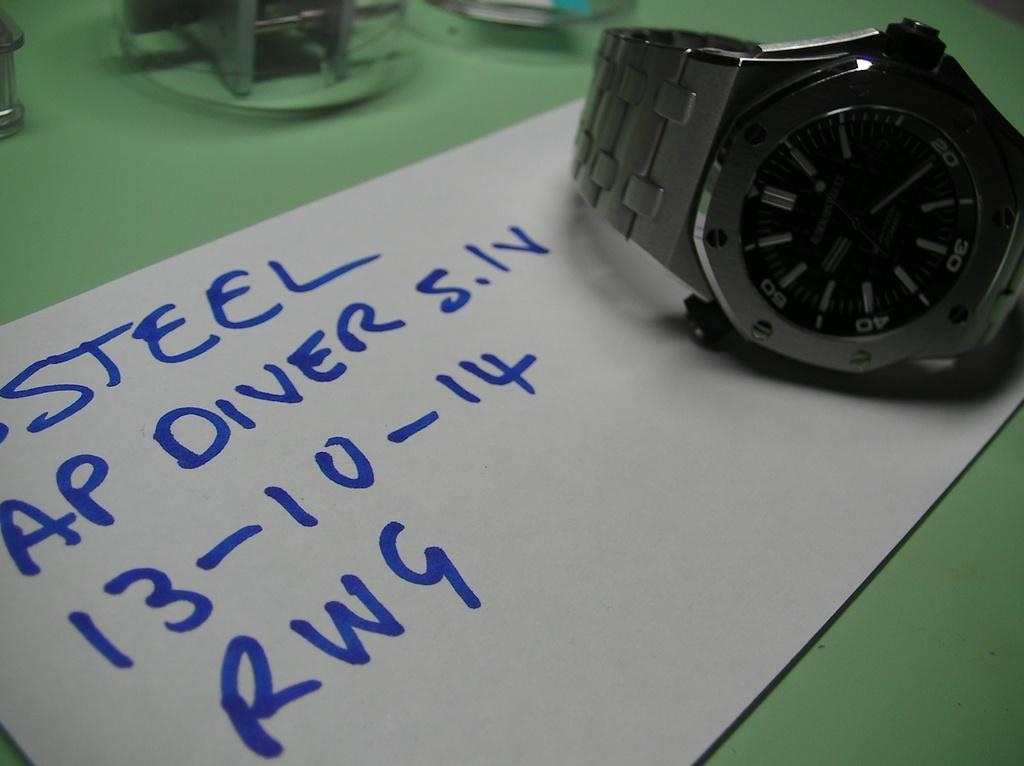Provide a one-sentence caption for the provided image. A watch on a piece of paper which reads Steel at the top. 